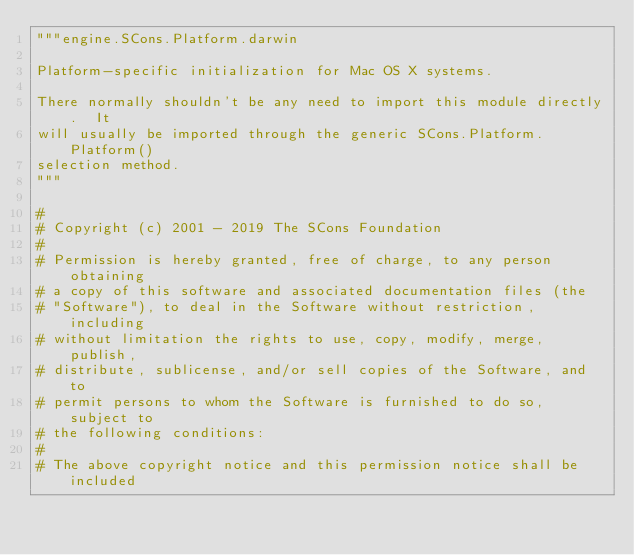Convert code to text. <code><loc_0><loc_0><loc_500><loc_500><_Python_>"""engine.SCons.Platform.darwin

Platform-specific initialization for Mac OS X systems.

There normally shouldn't be any need to import this module directly.  It
will usually be imported through the generic SCons.Platform.Platform()
selection method.
"""

#
# Copyright (c) 2001 - 2019 The SCons Foundation
#
# Permission is hereby granted, free of charge, to any person obtaining
# a copy of this software and associated documentation files (the
# "Software"), to deal in the Software without restriction, including
# without limitation the rights to use, copy, modify, merge, publish,
# distribute, sublicense, and/or sell copies of the Software, and to
# permit persons to whom the Software is furnished to do so, subject to
# the following conditions:
#
# The above copyright notice and this permission notice shall be included</code> 